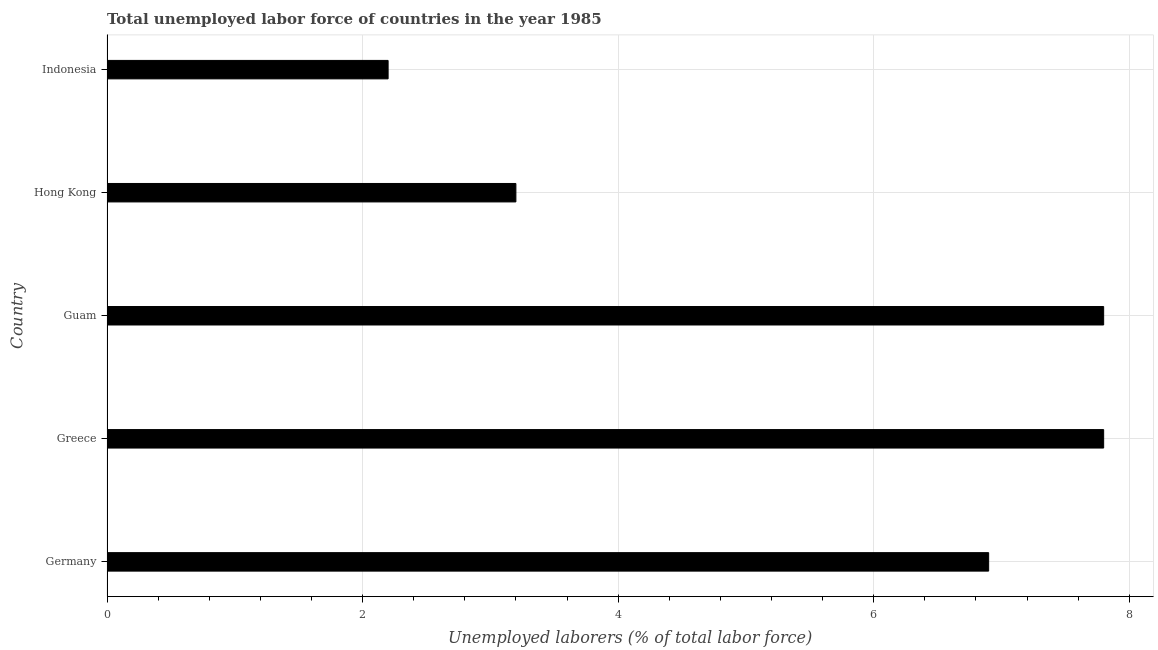Does the graph contain any zero values?
Your answer should be very brief. No. What is the title of the graph?
Make the answer very short. Total unemployed labor force of countries in the year 1985. What is the label or title of the X-axis?
Keep it short and to the point. Unemployed laborers (% of total labor force). What is the total unemployed labour force in Greece?
Your response must be concise. 7.8. Across all countries, what is the maximum total unemployed labour force?
Your answer should be very brief. 7.8. Across all countries, what is the minimum total unemployed labour force?
Offer a very short reply. 2.2. What is the sum of the total unemployed labour force?
Provide a succinct answer. 27.9. What is the difference between the total unemployed labour force in Germany and Greece?
Offer a terse response. -0.9. What is the average total unemployed labour force per country?
Keep it short and to the point. 5.58. What is the median total unemployed labour force?
Ensure brevity in your answer.  6.9. In how many countries, is the total unemployed labour force greater than 6.8 %?
Offer a very short reply. 3. What is the ratio of the total unemployed labour force in Greece to that in Guam?
Make the answer very short. 1. Is the difference between the total unemployed labour force in Guam and Hong Kong greater than the difference between any two countries?
Your answer should be very brief. No. What is the difference between the highest and the second highest total unemployed labour force?
Give a very brief answer. 0. How many bars are there?
Your answer should be compact. 5. How many countries are there in the graph?
Keep it short and to the point. 5. What is the difference between two consecutive major ticks on the X-axis?
Offer a very short reply. 2. What is the Unemployed laborers (% of total labor force) in Germany?
Give a very brief answer. 6.9. What is the Unemployed laborers (% of total labor force) of Greece?
Provide a short and direct response. 7.8. What is the Unemployed laborers (% of total labor force) in Guam?
Your answer should be very brief. 7.8. What is the Unemployed laborers (% of total labor force) in Hong Kong?
Your answer should be compact. 3.2. What is the Unemployed laborers (% of total labor force) of Indonesia?
Your answer should be compact. 2.2. What is the difference between the Unemployed laborers (% of total labor force) in Germany and Hong Kong?
Your answer should be very brief. 3.7. What is the ratio of the Unemployed laborers (% of total labor force) in Germany to that in Greece?
Your answer should be very brief. 0.89. What is the ratio of the Unemployed laborers (% of total labor force) in Germany to that in Guam?
Ensure brevity in your answer.  0.89. What is the ratio of the Unemployed laborers (% of total labor force) in Germany to that in Hong Kong?
Provide a succinct answer. 2.16. What is the ratio of the Unemployed laborers (% of total labor force) in Germany to that in Indonesia?
Keep it short and to the point. 3.14. What is the ratio of the Unemployed laborers (% of total labor force) in Greece to that in Guam?
Provide a succinct answer. 1. What is the ratio of the Unemployed laborers (% of total labor force) in Greece to that in Hong Kong?
Ensure brevity in your answer.  2.44. What is the ratio of the Unemployed laborers (% of total labor force) in Greece to that in Indonesia?
Your answer should be compact. 3.54. What is the ratio of the Unemployed laborers (% of total labor force) in Guam to that in Hong Kong?
Make the answer very short. 2.44. What is the ratio of the Unemployed laborers (% of total labor force) in Guam to that in Indonesia?
Your answer should be compact. 3.54. What is the ratio of the Unemployed laborers (% of total labor force) in Hong Kong to that in Indonesia?
Your answer should be compact. 1.46. 